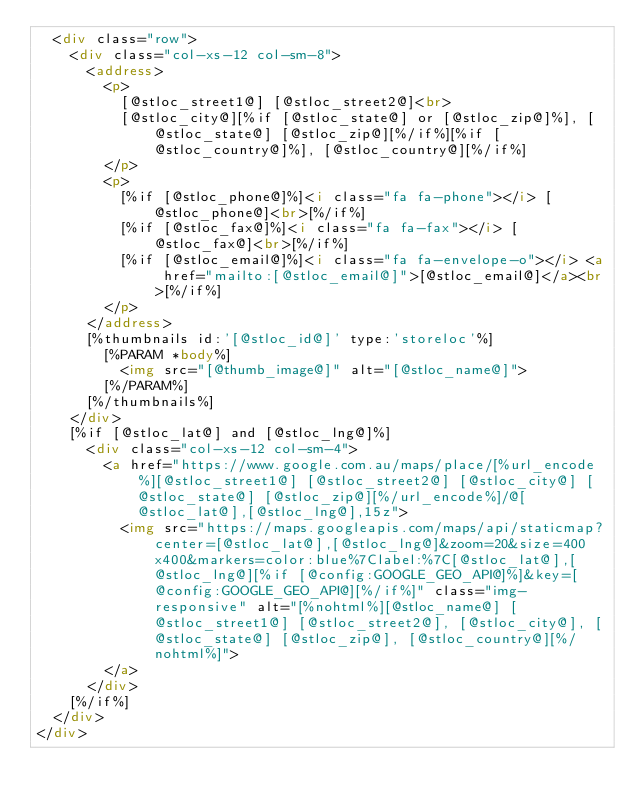Convert code to text. <code><loc_0><loc_0><loc_500><loc_500><_HTML_>	<div class="row">
		<div class="col-xs-12 col-sm-8">
			<address>
				<p>
					[@stloc_street1@] [@stloc_street2@]<br>
					[@stloc_city@][%if [@stloc_state@] or [@stloc_zip@]%], [@stloc_state@] [@stloc_zip@][%/if%][%if [@stloc_country@]%], [@stloc_country@][%/if%]
				</p>
				<p>
					[%if [@stloc_phone@]%]<i class="fa fa-phone"></i> [@stloc_phone@]<br>[%/if%]
					[%if [@stloc_fax@]%]<i class="fa fa-fax"></i> [@stloc_fax@]<br>[%/if%]
					[%if [@stloc_email@]%]<i class="fa fa-envelope-o"></i> <a href="mailto:[@stloc_email@]">[@stloc_email@]</a><br>[%/if%]
				</p>
			</address>
			[%thumbnails id:'[@stloc_id@]' type:'storeloc'%]
				[%PARAM *body%]
					<img src="[@thumb_image@]" alt="[@stloc_name@]">
				[%/PARAM%]
			[%/thumbnails%]
		</div>
		[%if [@stloc_lat@] and [@stloc_lng@]%]
			<div class="col-xs-12 col-sm-4">
				<a href="https://www.google.com.au/maps/place/[%url_encode%][@stloc_street1@] [@stloc_street2@] [@stloc_city@] [@stloc_state@] [@stloc_zip@][%/url_encode%]/@[@stloc_lat@],[@stloc_lng@],15z">
					<img src="https://maps.googleapis.com/maps/api/staticmap?center=[@stloc_lat@],[@stloc_lng@]&zoom=20&size=400x400&markers=color:blue%7Clabel:%7C[@stloc_lat@],[@stloc_lng@][%if [@config:GOOGLE_GEO_API@]%]&key=[@config:GOOGLE_GEO_API@][%/if%]" class="img-responsive" alt="[%nohtml%][@stloc_name@] [@stloc_street1@] [@stloc_street2@], [@stloc_city@], [@stloc_state@] [@stloc_zip@], [@stloc_country@][%/nohtml%]">
				</a>
			</div>
		[%/if%]
	</div>
</div>
</code> 